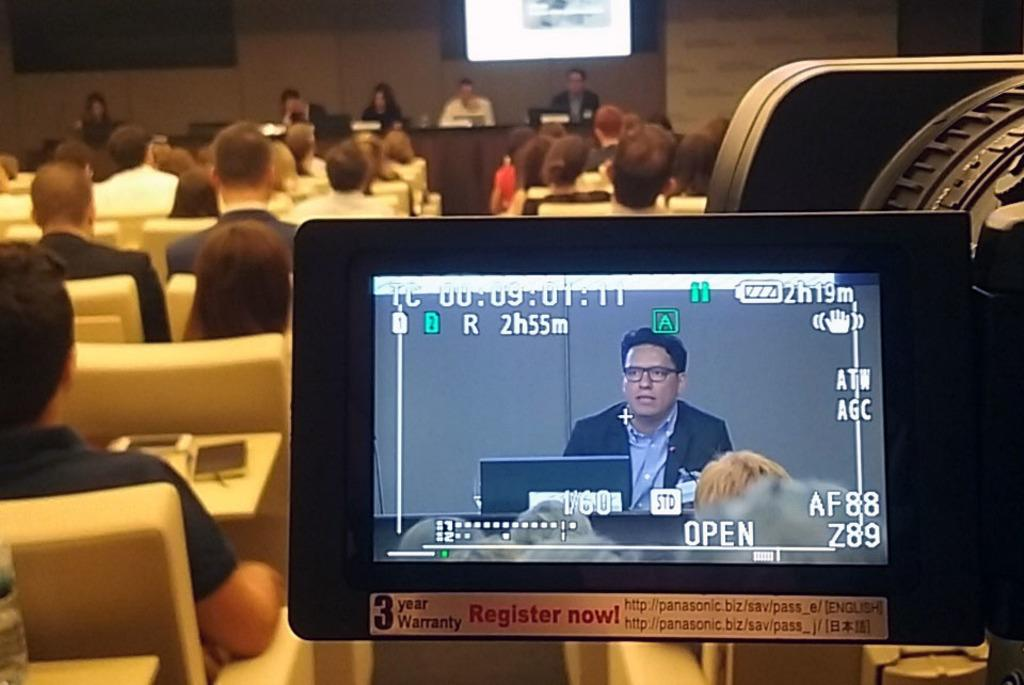What is the main subject on the display screen in the image? There is a person on a display screen in the image. What are the persons in the image doing? The persons in the image are sitting on chairs. What type of structure can be seen in the image? There are walls visible in the image. How many deer can be seen grazing in the image? There are no deer present in the image; it features a person on a display screen and persons sitting on chairs. What type of wax is being used by the secretary in the image? There is no secretary or wax present in the image. 